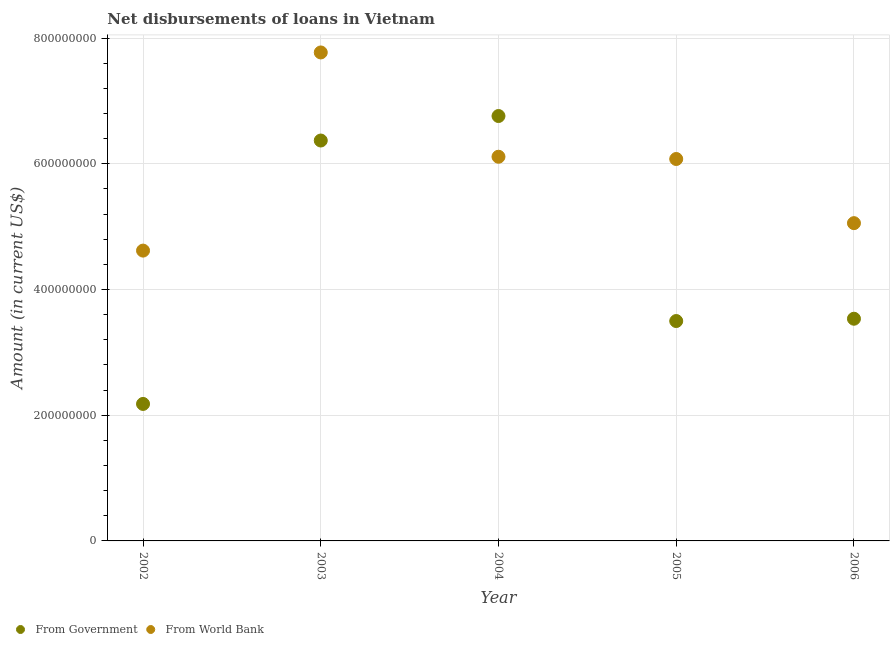What is the net disbursements of loan from world bank in 2003?
Ensure brevity in your answer.  7.77e+08. Across all years, what is the maximum net disbursements of loan from world bank?
Your answer should be compact. 7.77e+08. Across all years, what is the minimum net disbursements of loan from world bank?
Your answer should be very brief. 4.62e+08. In which year was the net disbursements of loan from government minimum?
Your answer should be very brief. 2002. What is the total net disbursements of loan from government in the graph?
Your answer should be very brief. 2.23e+09. What is the difference between the net disbursements of loan from government in 2003 and that in 2004?
Give a very brief answer. -3.90e+07. What is the difference between the net disbursements of loan from government in 2006 and the net disbursements of loan from world bank in 2005?
Offer a very short reply. -2.54e+08. What is the average net disbursements of loan from government per year?
Give a very brief answer. 4.47e+08. In the year 2006, what is the difference between the net disbursements of loan from government and net disbursements of loan from world bank?
Ensure brevity in your answer.  -1.52e+08. What is the ratio of the net disbursements of loan from world bank in 2004 to that in 2006?
Ensure brevity in your answer.  1.21. Is the net disbursements of loan from world bank in 2002 less than that in 2004?
Keep it short and to the point. Yes. What is the difference between the highest and the second highest net disbursements of loan from government?
Offer a terse response. 3.90e+07. What is the difference between the highest and the lowest net disbursements of loan from world bank?
Your answer should be very brief. 3.15e+08. How many dotlines are there?
Offer a very short reply. 2. How many years are there in the graph?
Offer a terse response. 5. What is the difference between two consecutive major ticks on the Y-axis?
Your answer should be compact. 2.00e+08. Does the graph contain any zero values?
Your answer should be compact. No. Where does the legend appear in the graph?
Offer a terse response. Bottom left. How many legend labels are there?
Give a very brief answer. 2. How are the legend labels stacked?
Ensure brevity in your answer.  Horizontal. What is the title of the graph?
Keep it short and to the point. Net disbursements of loans in Vietnam. Does "Largest city" appear as one of the legend labels in the graph?
Make the answer very short. No. What is the label or title of the X-axis?
Make the answer very short. Year. What is the label or title of the Y-axis?
Provide a succinct answer. Amount (in current US$). What is the Amount (in current US$) in From Government in 2002?
Provide a succinct answer. 2.18e+08. What is the Amount (in current US$) of From World Bank in 2002?
Your answer should be very brief. 4.62e+08. What is the Amount (in current US$) of From Government in 2003?
Your answer should be very brief. 6.37e+08. What is the Amount (in current US$) of From World Bank in 2003?
Provide a short and direct response. 7.77e+08. What is the Amount (in current US$) in From Government in 2004?
Ensure brevity in your answer.  6.76e+08. What is the Amount (in current US$) of From World Bank in 2004?
Keep it short and to the point. 6.11e+08. What is the Amount (in current US$) of From Government in 2005?
Your response must be concise. 3.50e+08. What is the Amount (in current US$) of From World Bank in 2005?
Offer a terse response. 6.08e+08. What is the Amount (in current US$) in From Government in 2006?
Keep it short and to the point. 3.53e+08. What is the Amount (in current US$) in From World Bank in 2006?
Provide a succinct answer. 5.05e+08. Across all years, what is the maximum Amount (in current US$) of From Government?
Offer a terse response. 6.76e+08. Across all years, what is the maximum Amount (in current US$) of From World Bank?
Your answer should be compact. 7.77e+08. Across all years, what is the minimum Amount (in current US$) of From Government?
Offer a terse response. 2.18e+08. Across all years, what is the minimum Amount (in current US$) of From World Bank?
Your response must be concise. 4.62e+08. What is the total Amount (in current US$) in From Government in the graph?
Make the answer very short. 2.23e+09. What is the total Amount (in current US$) in From World Bank in the graph?
Make the answer very short. 2.96e+09. What is the difference between the Amount (in current US$) in From Government in 2002 and that in 2003?
Your answer should be very brief. -4.19e+08. What is the difference between the Amount (in current US$) in From World Bank in 2002 and that in 2003?
Make the answer very short. -3.15e+08. What is the difference between the Amount (in current US$) in From Government in 2002 and that in 2004?
Keep it short and to the point. -4.58e+08. What is the difference between the Amount (in current US$) in From World Bank in 2002 and that in 2004?
Keep it short and to the point. -1.49e+08. What is the difference between the Amount (in current US$) of From Government in 2002 and that in 2005?
Give a very brief answer. -1.32e+08. What is the difference between the Amount (in current US$) in From World Bank in 2002 and that in 2005?
Keep it short and to the point. -1.46e+08. What is the difference between the Amount (in current US$) in From Government in 2002 and that in 2006?
Your answer should be very brief. -1.36e+08. What is the difference between the Amount (in current US$) of From World Bank in 2002 and that in 2006?
Provide a succinct answer. -4.37e+07. What is the difference between the Amount (in current US$) of From Government in 2003 and that in 2004?
Offer a terse response. -3.90e+07. What is the difference between the Amount (in current US$) in From World Bank in 2003 and that in 2004?
Provide a succinct answer. 1.66e+08. What is the difference between the Amount (in current US$) of From Government in 2003 and that in 2005?
Your answer should be compact. 2.87e+08. What is the difference between the Amount (in current US$) in From World Bank in 2003 and that in 2005?
Give a very brief answer. 1.69e+08. What is the difference between the Amount (in current US$) in From Government in 2003 and that in 2006?
Keep it short and to the point. 2.83e+08. What is the difference between the Amount (in current US$) of From World Bank in 2003 and that in 2006?
Offer a very short reply. 2.72e+08. What is the difference between the Amount (in current US$) in From Government in 2004 and that in 2005?
Give a very brief answer. 3.26e+08. What is the difference between the Amount (in current US$) of From World Bank in 2004 and that in 2005?
Provide a short and direct response. 3.59e+06. What is the difference between the Amount (in current US$) in From Government in 2004 and that in 2006?
Your answer should be very brief. 3.22e+08. What is the difference between the Amount (in current US$) of From World Bank in 2004 and that in 2006?
Your answer should be compact. 1.06e+08. What is the difference between the Amount (in current US$) in From Government in 2005 and that in 2006?
Provide a succinct answer. -3.66e+06. What is the difference between the Amount (in current US$) in From World Bank in 2005 and that in 2006?
Make the answer very short. 1.02e+08. What is the difference between the Amount (in current US$) in From Government in 2002 and the Amount (in current US$) in From World Bank in 2003?
Your answer should be compact. -5.59e+08. What is the difference between the Amount (in current US$) in From Government in 2002 and the Amount (in current US$) in From World Bank in 2004?
Provide a short and direct response. -3.93e+08. What is the difference between the Amount (in current US$) of From Government in 2002 and the Amount (in current US$) of From World Bank in 2005?
Offer a terse response. -3.90e+08. What is the difference between the Amount (in current US$) in From Government in 2002 and the Amount (in current US$) in From World Bank in 2006?
Ensure brevity in your answer.  -2.88e+08. What is the difference between the Amount (in current US$) in From Government in 2003 and the Amount (in current US$) in From World Bank in 2004?
Make the answer very short. 2.58e+07. What is the difference between the Amount (in current US$) of From Government in 2003 and the Amount (in current US$) of From World Bank in 2005?
Provide a short and direct response. 2.94e+07. What is the difference between the Amount (in current US$) in From Government in 2003 and the Amount (in current US$) in From World Bank in 2006?
Offer a very short reply. 1.31e+08. What is the difference between the Amount (in current US$) of From Government in 2004 and the Amount (in current US$) of From World Bank in 2005?
Keep it short and to the point. 6.84e+07. What is the difference between the Amount (in current US$) of From Government in 2004 and the Amount (in current US$) of From World Bank in 2006?
Keep it short and to the point. 1.70e+08. What is the difference between the Amount (in current US$) of From Government in 2005 and the Amount (in current US$) of From World Bank in 2006?
Provide a succinct answer. -1.56e+08. What is the average Amount (in current US$) in From Government per year?
Ensure brevity in your answer.  4.47e+08. What is the average Amount (in current US$) in From World Bank per year?
Offer a very short reply. 5.93e+08. In the year 2002, what is the difference between the Amount (in current US$) in From Government and Amount (in current US$) in From World Bank?
Give a very brief answer. -2.44e+08. In the year 2003, what is the difference between the Amount (in current US$) in From Government and Amount (in current US$) in From World Bank?
Offer a very short reply. -1.40e+08. In the year 2004, what is the difference between the Amount (in current US$) of From Government and Amount (in current US$) of From World Bank?
Provide a short and direct response. 6.48e+07. In the year 2005, what is the difference between the Amount (in current US$) of From Government and Amount (in current US$) of From World Bank?
Your answer should be compact. -2.58e+08. In the year 2006, what is the difference between the Amount (in current US$) of From Government and Amount (in current US$) of From World Bank?
Ensure brevity in your answer.  -1.52e+08. What is the ratio of the Amount (in current US$) of From Government in 2002 to that in 2003?
Your response must be concise. 0.34. What is the ratio of the Amount (in current US$) of From World Bank in 2002 to that in 2003?
Make the answer very short. 0.59. What is the ratio of the Amount (in current US$) in From Government in 2002 to that in 2004?
Provide a succinct answer. 0.32. What is the ratio of the Amount (in current US$) in From World Bank in 2002 to that in 2004?
Your answer should be compact. 0.76. What is the ratio of the Amount (in current US$) in From Government in 2002 to that in 2005?
Make the answer very short. 0.62. What is the ratio of the Amount (in current US$) in From World Bank in 2002 to that in 2005?
Make the answer very short. 0.76. What is the ratio of the Amount (in current US$) in From Government in 2002 to that in 2006?
Keep it short and to the point. 0.62. What is the ratio of the Amount (in current US$) in From World Bank in 2002 to that in 2006?
Provide a succinct answer. 0.91. What is the ratio of the Amount (in current US$) of From Government in 2003 to that in 2004?
Offer a terse response. 0.94. What is the ratio of the Amount (in current US$) in From World Bank in 2003 to that in 2004?
Your response must be concise. 1.27. What is the ratio of the Amount (in current US$) of From Government in 2003 to that in 2005?
Give a very brief answer. 1.82. What is the ratio of the Amount (in current US$) in From World Bank in 2003 to that in 2005?
Your answer should be compact. 1.28. What is the ratio of the Amount (in current US$) of From Government in 2003 to that in 2006?
Your answer should be compact. 1.8. What is the ratio of the Amount (in current US$) of From World Bank in 2003 to that in 2006?
Give a very brief answer. 1.54. What is the ratio of the Amount (in current US$) of From Government in 2004 to that in 2005?
Ensure brevity in your answer.  1.93. What is the ratio of the Amount (in current US$) of From World Bank in 2004 to that in 2005?
Ensure brevity in your answer.  1.01. What is the ratio of the Amount (in current US$) in From Government in 2004 to that in 2006?
Make the answer very short. 1.91. What is the ratio of the Amount (in current US$) of From World Bank in 2004 to that in 2006?
Offer a very short reply. 1.21. What is the ratio of the Amount (in current US$) in From World Bank in 2005 to that in 2006?
Provide a short and direct response. 1.2. What is the difference between the highest and the second highest Amount (in current US$) of From Government?
Offer a very short reply. 3.90e+07. What is the difference between the highest and the second highest Amount (in current US$) of From World Bank?
Give a very brief answer. 1.66e+08. What is the difference between the highest and the lowest Amount (in current US$) in From Government?
Provide a short and direct response. 4.58e+08. What is the difference between the highest and the lowest Amount (in current US$) in From World Bank?
Ensure brevity in your answer.  3.15e+08. 